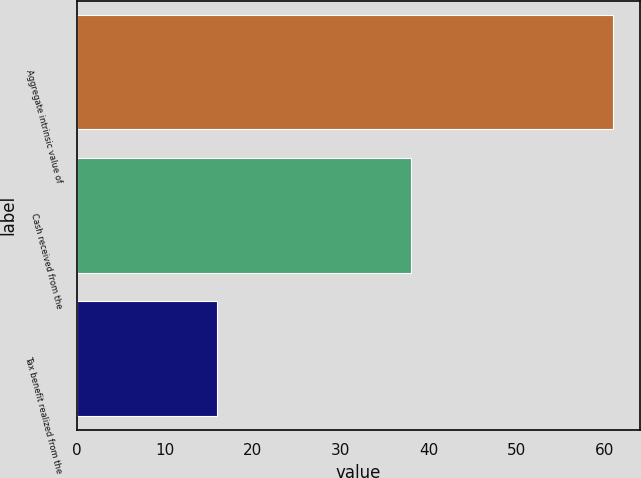Convert chart. <chart><loc_0><loc_0><loc_500><loc_500><bar_chart><fcel>Aggregate intrinsic value of<fcel>Cash received from the<fcel>Tax benefit realized from the<nl><fcel>61<fcel>38<fcel>16<nl></chart> 